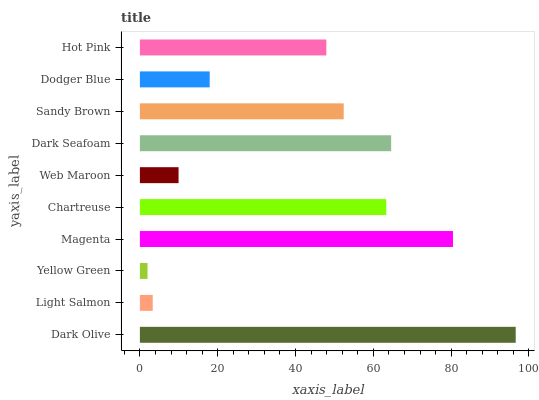Is Yellow Green the minimum?
Answer yes or no. Yes. Is Dark Olive the maximum?
Answer yes or no. Yes. Is Light Salmon the minimum?
Answer yes or no. No. Is Light Salmon the maximum?
Answer yes or no. No. Is Dark Olive greater than Light Salmon?
Answer yes or no. Yes. Is Light Salmon less than Dark Olive?
Answer yes or no. Yes. Is Light Salmon greater than Dark Olive?
Answer yes or no. No. Is Dark Olive less than Light Salmon?
Answer yes or no. No. Is Sandy Brown the high median?
Answer yes or no. Yes. Is Hot Pink the low median?
Answer yes or no. Yes. Is Hot Pink the high median?
Answer yes or no. No. Is Light Salmon the low median?
Answer yes or no. No. 